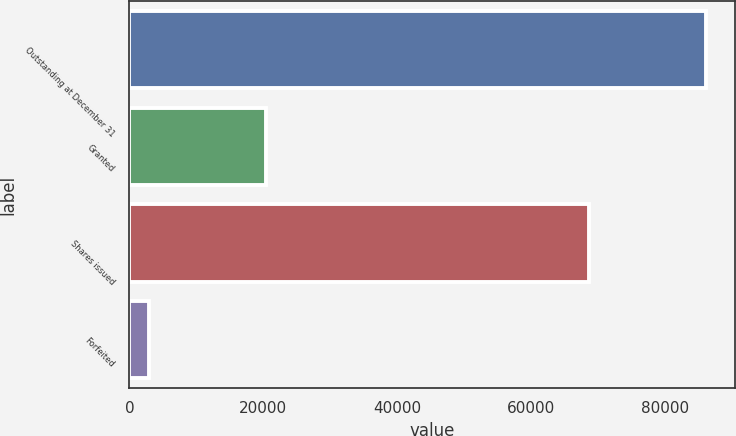Convert chart. <chart><loc_0><loc_0><loc_500><loc_500><bar_chart><fcel>Outstanding at December 31<fcel>Granted<fcel>Shares issued<fcel>Forfeited<nl><fcel>86050<fcel>20425<fcel>68625<fcel>3000<nl></chart> 